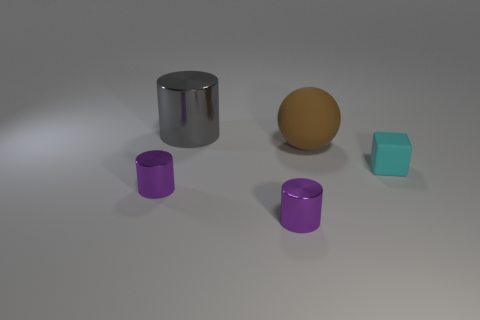Subtract all brown blocks. How many purple cylinders are left? 2 Subtract all large gray cylinders. How many cylinders are left? 2 Subtract 1 cylinders. How many cylinders are left? 2 Add 2 large brown things. How many objects exist? 7 Subtract all balls. How many objects are left? 4 Add 5 tiny purple metal cylinders. How many tiny purple metal cylinders exist? 7 Subtract 2 purple cylinders. How many objects are left? 3 Subtract all small cyan blocks. Subtract all big brown rubber balls. How many objects are left? 3 Add 1 big gray cylinders. How many big gray cylinders are left? 2 